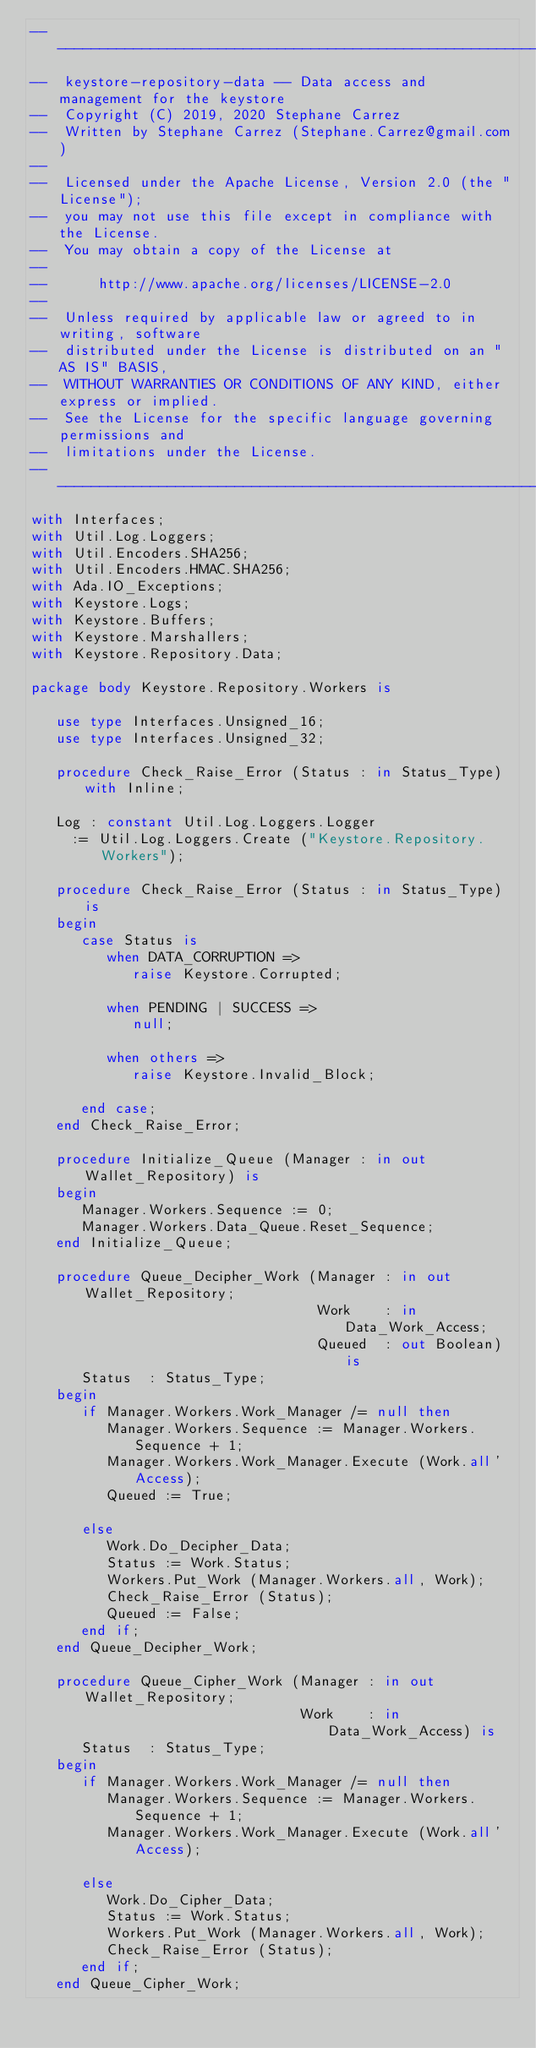Convert code to text. <code><loc_0><loc_0><loc_500><loc_500><_Ada_>-----------------------------------------------------------------------
--  keystore-repository-data -- Data access and management for the keystore
--  Copyright (C) 2019, 2020 Stephane Carrez
--  Written by Stephane Carrez (Stephane.Carrez@gmail.com)
--
--  Licensed under the Apache License, Version 2.0 (the "License");
--  you may not use this file except in compliance with the License.
--  You may obtain a copy of the License at
--
--      http://www.apache.org/licenses/LICENSE-2.0
--
--  Unless required by applicable law or agreed to in writing, software
--  distributed under the License is distributed on an "AS IS" BASIS,
--  WITHOUT WARRANTIES OR CONDITIONS OF ANY KIND, either express or implied.
--  See the License for the specific language governing permissions and
--  limitations under the License.
-----------------------------------------------------------------------
with Interfaces;
with Util.Log.Loggers;
with Util.Encoders.SHA256;
with Util.Encoders.HMAC.SHA256;
with Ada.IO_Exceptions;
with Keystore.Logs;
with Keystore.Buffers;
with Keystore.Marshallers;
with Keystore.Repository.Data;

package body Keystore.Repository.Workers is

   use type Interfaces.Unsigned_16;
   use type Interfaces.Unsigned_32;

   procedure Check_Raise_Error (Status : in Status_Type) with Inline;

   Log : constant Util.Log.Loggers.Logger
     := Util.Log.Loggers.Create ("Keystore.Repository.Workers");

   procedure Check_Raise_Error (Status : in Status_Type) is
   begin
      case Status is
         when DATA_CORRUPTION =>
            raise Keystore.Corrupted;

         when PENDING | SUCCESS =>
            null;

         when others =>
            raise Keystore.Invalid_Block;

      end case;
   end Check_Raise_Error;

   procedure Initialize_Queue (Manager : in out Wallet_Repository) is
   begin
      Manager.Workers.Sequence := 0;
      Manager.Workers.Data_Queue.Reset_Sequence;
   end Initialize_Queue;

   procedure Queue_Decipher_Work (Manager : in out Wallet_Repository;
                                  Work    : in Data_Work_Access;
                                  Queued  : out Boolean) is
      Status  : Status_Type;
   begin
      if Manager.Workers.Work_Manager /= null then
         Manager.Workers.Sequence := Manager.Workers.Sequence + 1;
         Manager.Workers.Work_Manager.Execute (Work.all'Access);
         Queued := True;

      else
         Work.Do_Decipher_Data;
         Status := Work.Status;
         Workers.Put_Work (Manager.Workers.all, Work);
         Check_Raise_Error (Status);
         Queued := False;
      end if;
   end Queue_Decipher_Work;

   procedure Queue_Cipher_Work (Manager : in out Wallet_Repository;
                                Work    : in Data_Work_Access) is
      Status  : Status_Type;
   begin
      if Manager.Workers.Work_Manager /= null then
         Manager.Workers.Sequence := Manager.Workers.Sequence + 1;
         Manager.Workers.Work_Manager.Execute (Work.all'Access);

      else
         Work.Do_Cipher_Data;
         Status := Work.Status;
         Workers.Put_Work (Manager.Workers.all, Work);
         Check_Raise_Error (Status);
      end if;
   end Queue_Cipher_Work;
</code> 